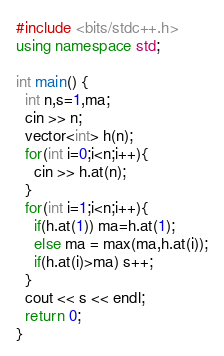Convert code to text. <code><loc_0><loc_0><loc_500><loc_500><_C++_>#include <bits/stdc++.h>
using namespace std;

int main() {
  int n,s=1,ma;
  cin >> n;
  vector<int> h(n);
  for(int i=0;i<n;i++){
    cin >> h.at(n);
  }
  for(int i=1;i<n;i++){
    if(h.at(1)) ma=h.at(1);
    else ma = max(ma,h.at(i));
    if(h.at(i)>ma) s++;
  }
  cout << s << endl;
  return 0;
}
</code> 